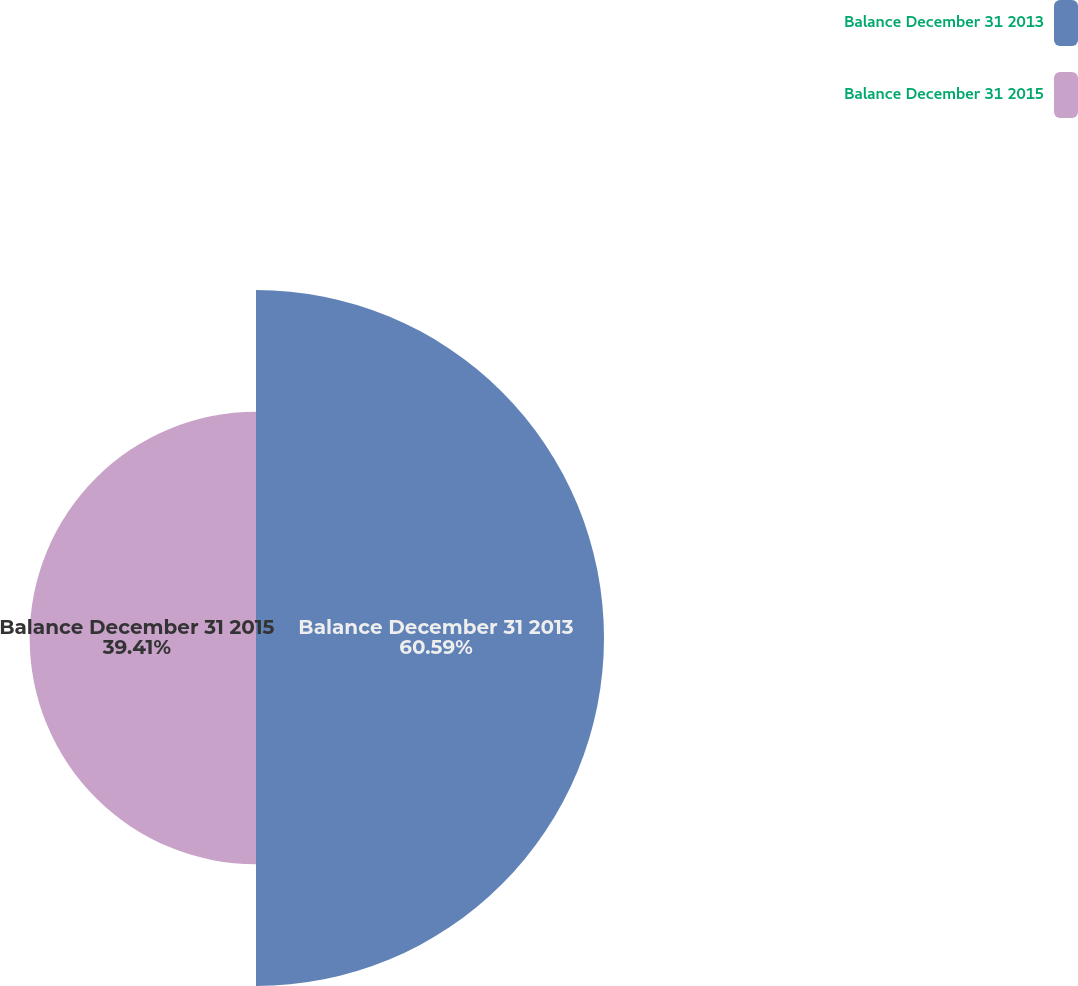Convert chart to OTSL. <chart><loc_0><loc_0><loc_500><loc_500><pie_chart><fcel>Balance December 31 2013<fcel>Balance December 31 2015<nl><fcel>60.59%<fcel>39.41%<nl></chart> 